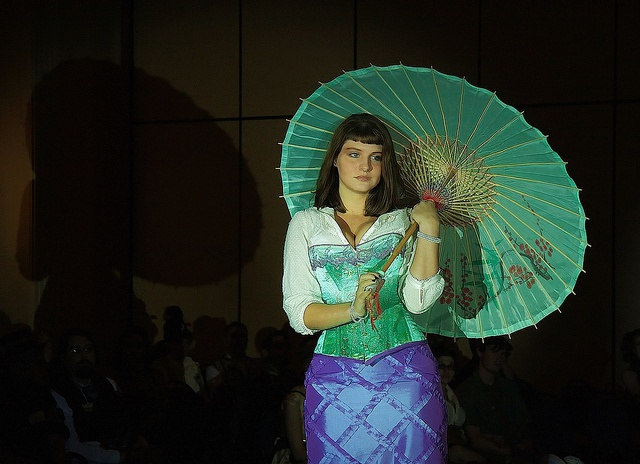Describe the objects in this image and their specific colors. I can see umbrella in black, teal, and darkgreen tones, people in black, tan, blue, and darkgray tones, people in black, purple, and gray tones, people in black and gray tones, and people in black tones in this image. 